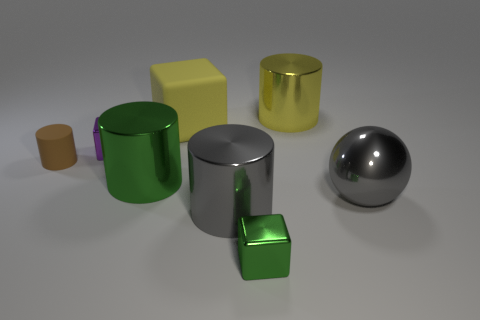Is there a big shiny cylinder that has the same color as the sphere?
Offer a terse response. Yes. What material is the gray sphere?
Make the answer very short. Metal. What number of other things have the same shape as the purple shiny object?
Give a very brief answer. 2. Are there any objects on the left side of the gray shiny cylinder?
Offer a very short reply. Yes. Is the shape of the green thing on the left side of the large yellow rubber object the same as the large thing that is behind the big block?
Offer a terse response. Yes. There is a small brown object that is the same shape as the large green metal object; what material is it?
Your response must be concise. Rubber. How many cylinders are either gray things or brown things?
Make the answer very short. 2. How many gray objects are made of the same material as the green block?
Your answer should be compact. 2. Is the big gray thing right of the big yellow metallic cylinder made of the same material as the large yellow object that is to the left of the green block?
Offer a terse response. No. There is a large cylinder right of the small object in front of the big green thing; how many big cylinders are in front of it?
Ensure brevity in your answer.  2. 